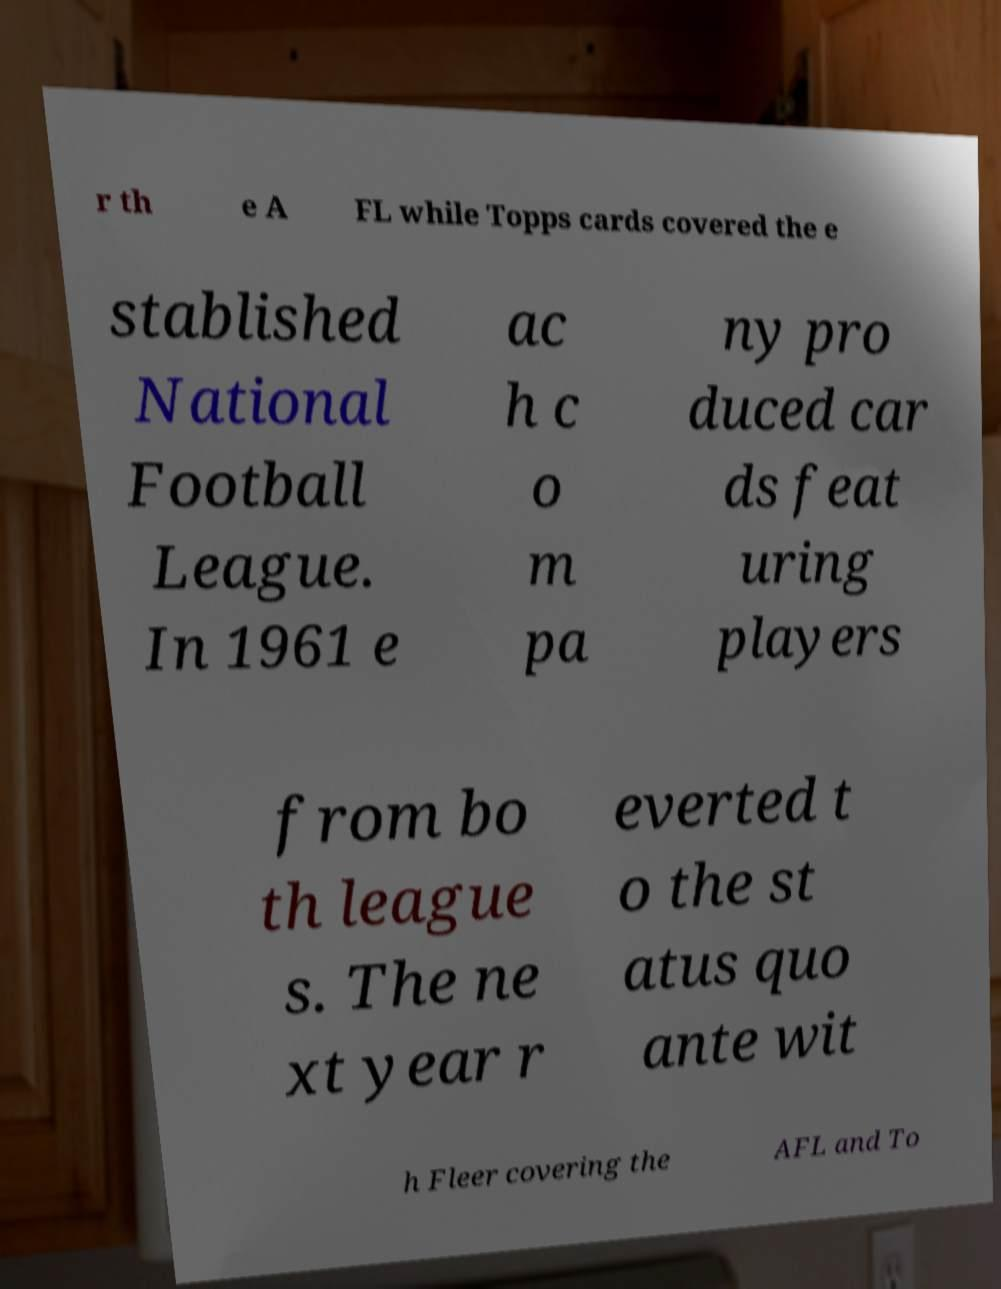What messages or text are displayed in this image? I need them in a readable, typed format. r th e A FL while Topps cards covered the e stablished National Football League. In 1961 e ac h c o m pa ny pro duced car ds feat uring players from bo th league s. The ne xt year r everted t o the st atus quo ante wit h Fleer covering the AFL and To 